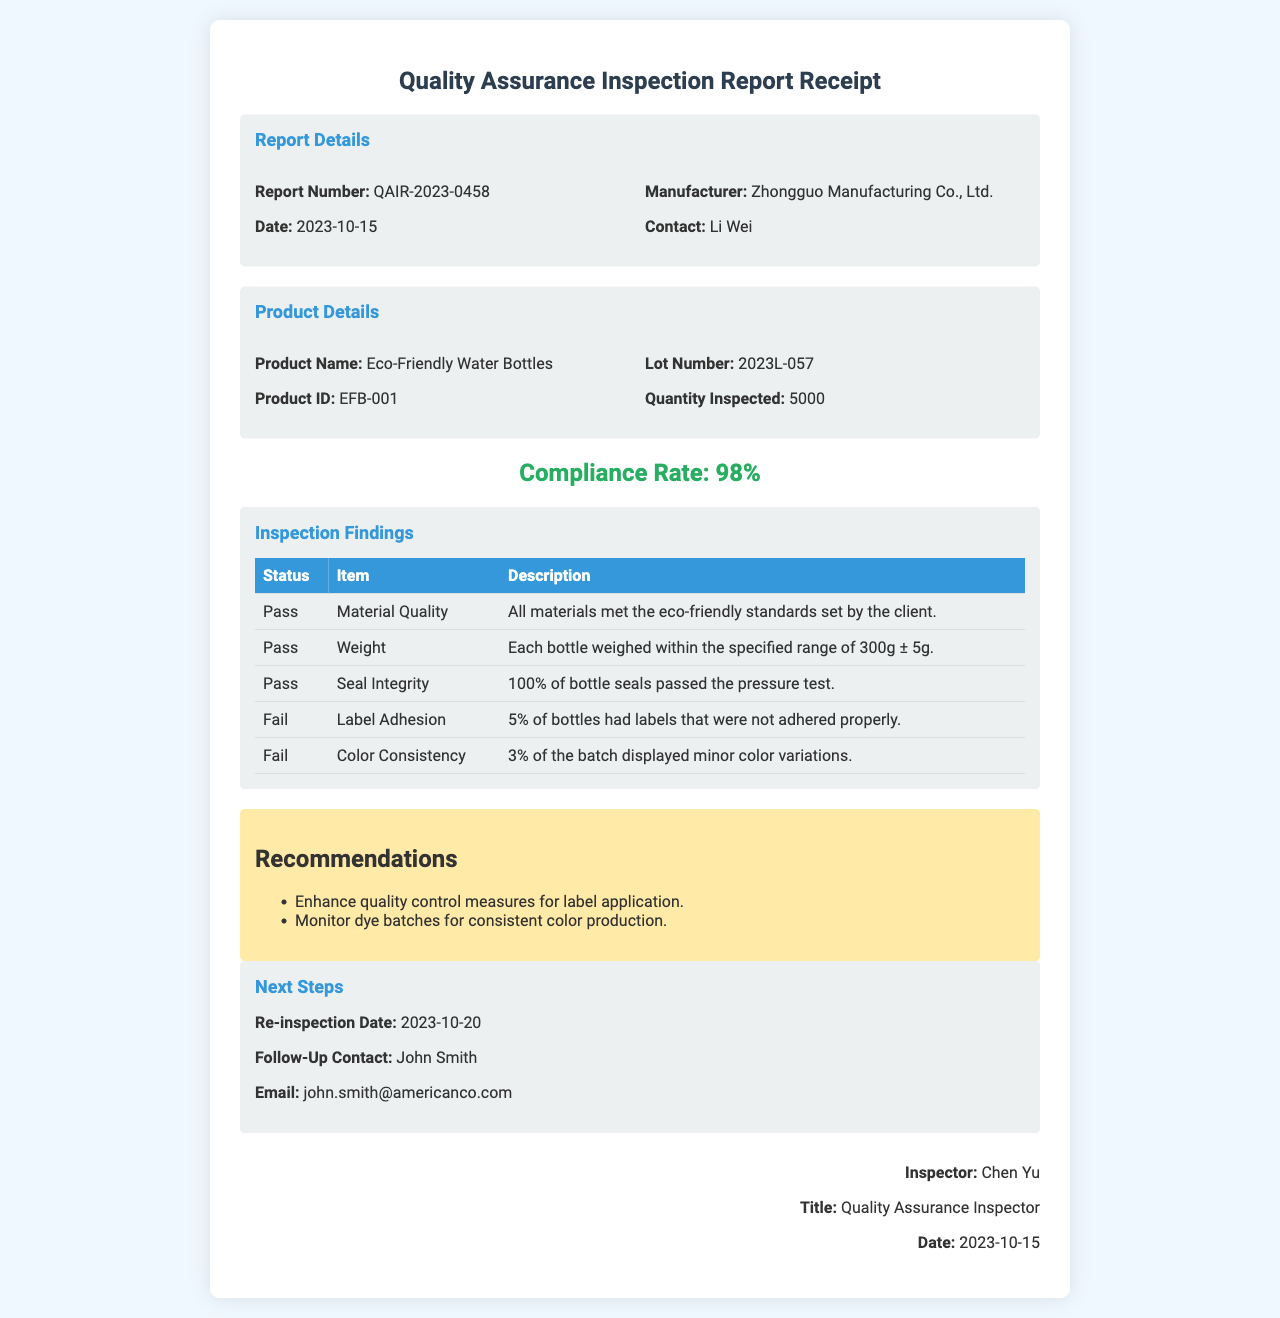What is the report number? The report number is stated as QAIR-2023-0458 in the document.
Answer: QAIR-2023-0458 Who is the contact person at the manufacturer? The contact person listed for the manufacturer is Li Wei.
Answer: Li Wei What is the product name? The product name is mentioned as Eco-Friendly Water Bottles.
Answer: Eco-Friendly Water Bottles What was the compliance rate? The compliance rate, which summarizes the findings, is displayed as 98%.
Answer: 98% How many bottles were inspected? The quantity inspected is specified as 5000 in the product details section.
Answer: 5000 What is the date for the re-inspection? The re-inspection date is provided as 2023-10-20.
Answer: 2023-10-20 What was the failure rate for label adhesion? The report states that 5% of bottles failed for label adhesion.
Answer: 5% What recommendations were given? Recommendations include enhancing quality control measures for label application and monitoring dye batches.
Answer: Enhance quality control measures for label application What is the name of the inspector? The inspector's name, as signed at the end of the report, is Chen Yu.
Answer: Chen Yu 